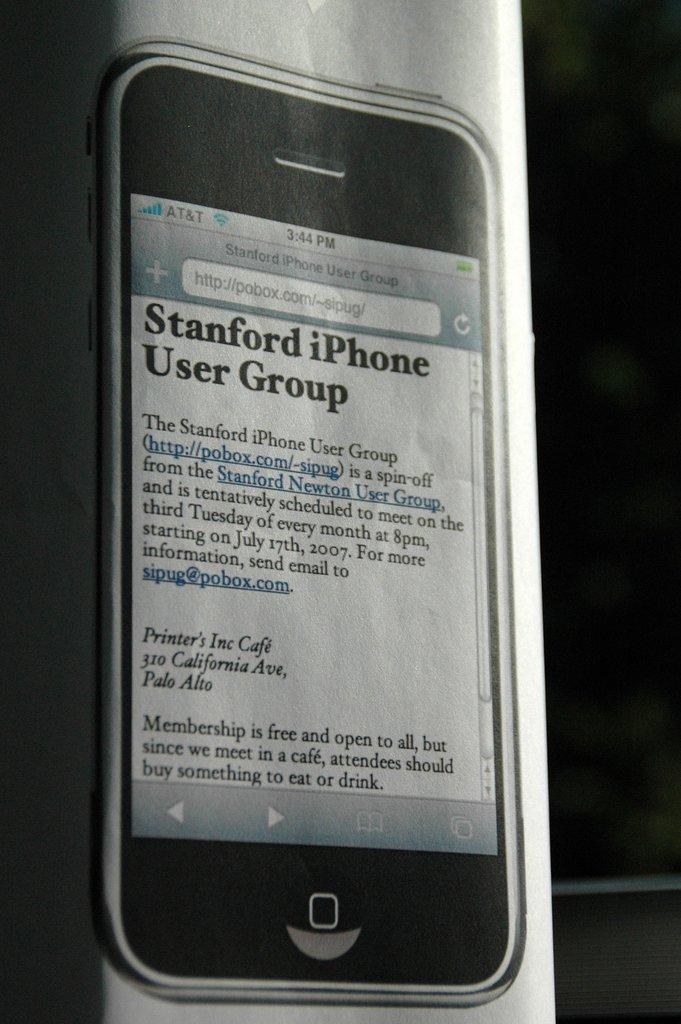What user group is this message written for?
Offer a very short reply. Stanford iphone user group. What is the time displayed?
Provide a short and direct response. 3:44. 